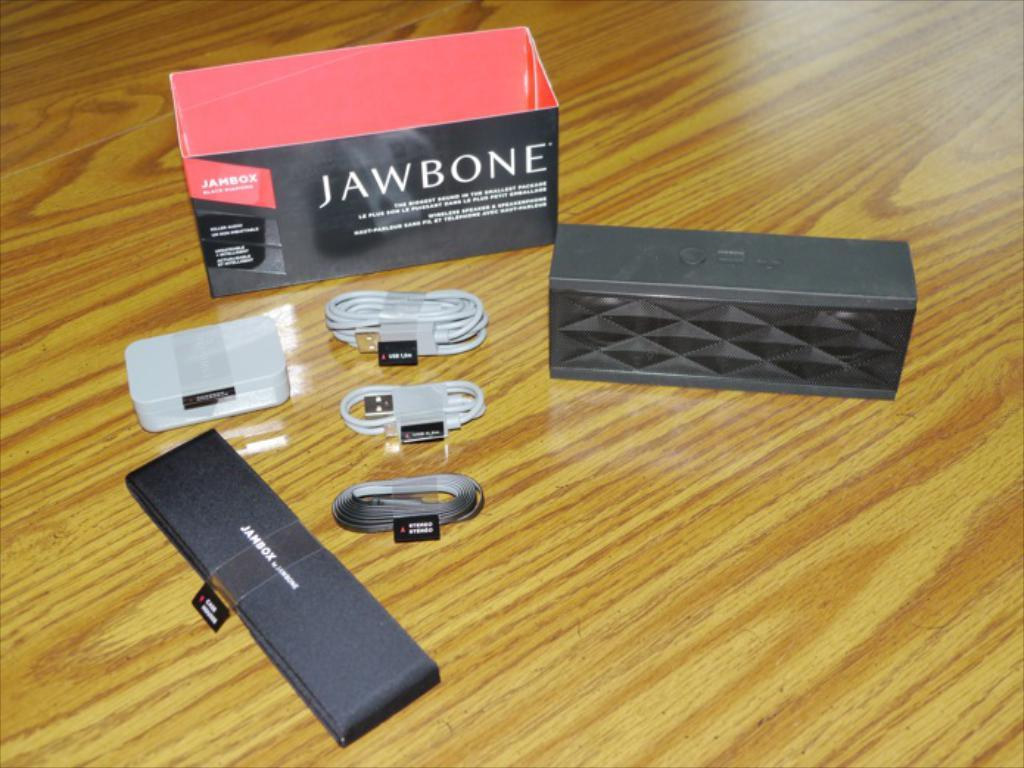<image>
Relay a brief, clear account of the picture shown. Jawbone package of wires that are on the floor. 